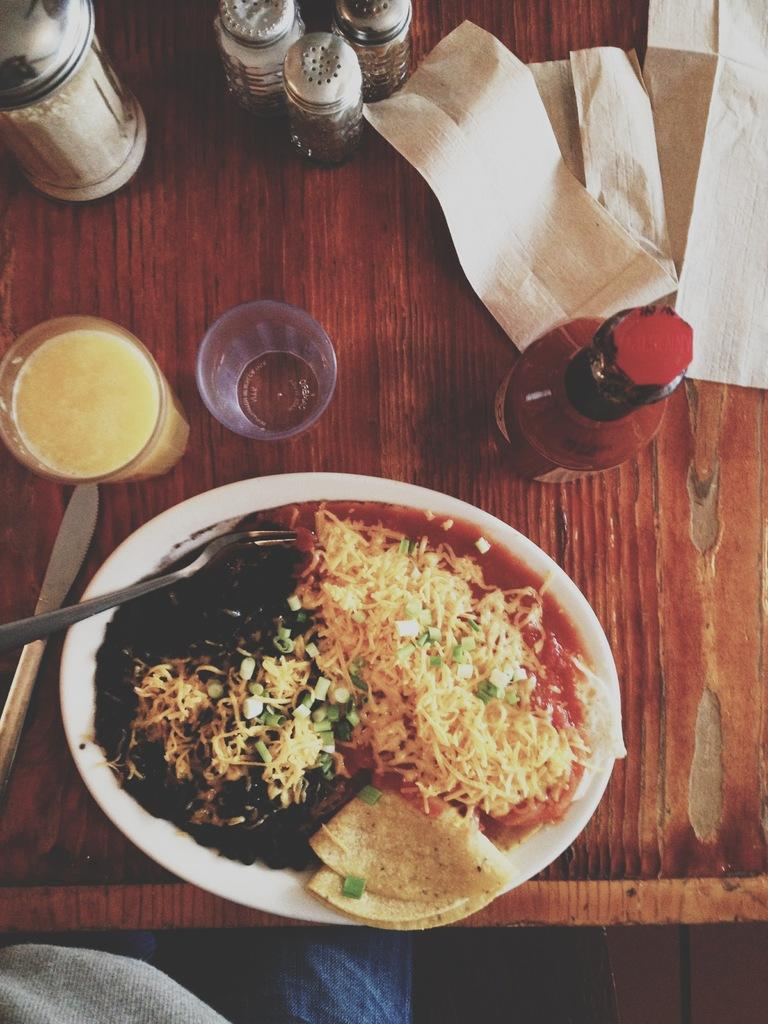What type of table is in the image? There is a brown table in the image. What is on top of the table? There is a plate, food, a glass, and bottles on the table. What is on the plate? There is food on the plate. What can be used for drinking in the image? There is a glass on the table that can be used for drinking. Is there a bone visible on the table in the image? No, there is no bone present in the image. What type of addition problem can be solved using the bottles on the table? There is no addition problem present in the image; it is a still image of a table with various objects on it. 